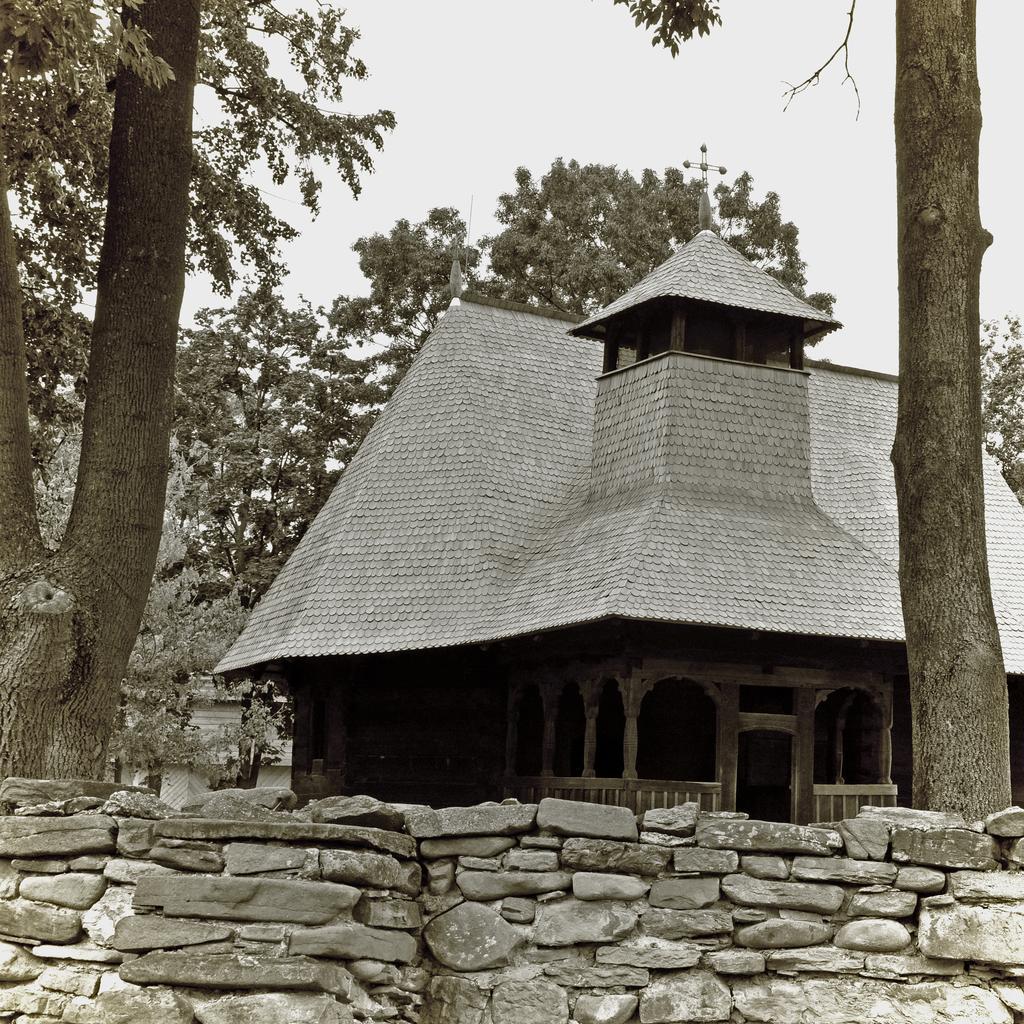How would you summarize this image in a sentence or two? In this image, we can see a stone fence and there is a shed. In the background, there are many trees. 